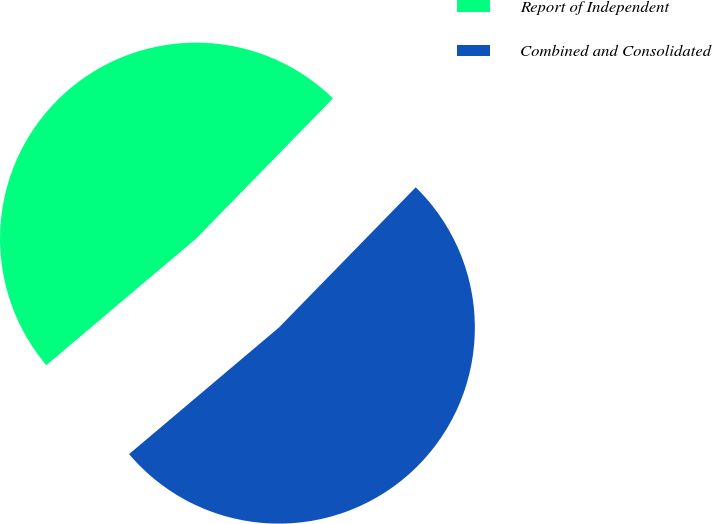Convert chart to OTSL. <chart><loc_0><loc_0><loc_500><loc_500><pie_chart><fcel>Report of Independent<fcel>Combined and Consolidated<nl><fcel>48.47%<fcel>51.53%<nl></chart> 